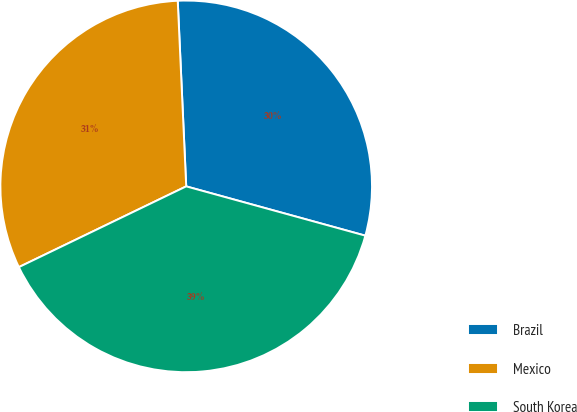Convert chart to OTSL. <chart><loc_0><loc_0><loc_500><loc_500><pie_chart><fcel>Brazil<fcel>Mexico<fcel>South Korea<nl><fcel>30.0%<fcel>31.43%<fcel>38.57%<nl></chart> 